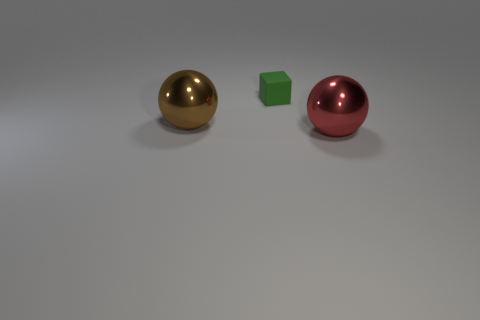Is there anything else that is the same size as the green cube?
Provide a short and direct response. No. What is the color of the shiny object that is on the right side of the tiny thing?
Your response must be concise. Red. The small green matte object has what shape?
Give a very brief answer. Cube. What is the material of the large object to the right of the large shiny thing that is to the left of the small matte cube?
Make the answer very short. Metal. How many other things are there of the same material as the brown thing?
Your response must be concise. 1. Is the number of brown metallic objects that are in front of the brown metallic ball greater than the number of tiny things left of the small green matte thing?
Offer a very short reply. No. Is there a gray thing of the same shape as the red object?
Provide a short and direct response. No. There is a brown metal thing that is the same size as the red sphere; what shape is it?
Offer a very short reply. Sphere. The big thing on the right side of the rubber block has what shape?
Your response must be concise. Sphere. Is the number of big red objects that are in front of the large red object less than the number of shiny balls on the right side of the small rubber object?
Make the answer very short. Yes. 